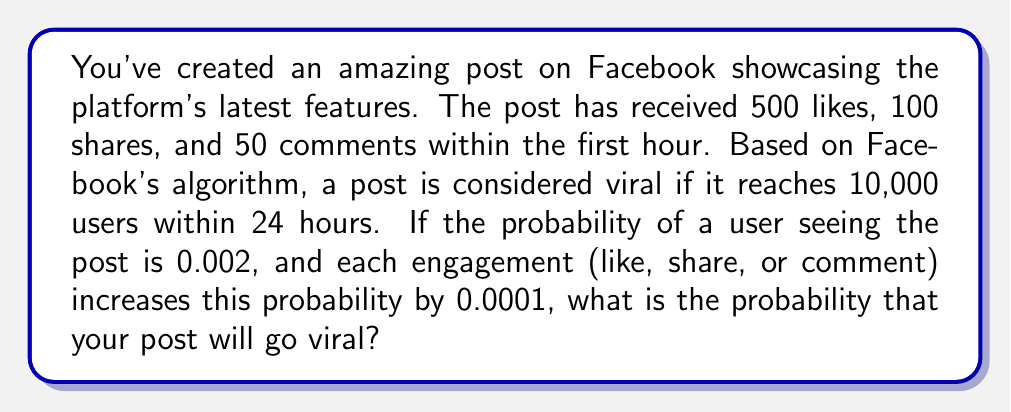Show me your answer to this math problem. Let's approach this step-by-step:

1) First, we need to calculate the adjusted probability of a user seeing the post:
   Base probability: 0.002
   Increase due to engagements: $(500 + 100 + 50) \times 0.0001 = 0.065$
   Adjusted probability: $p = 0.002 + 0.065 = 0.067$

2) The post needs to reach 10,000 users to be considered viral. We can model this as a binomial distribution, where success is defined as a user seeing the post.

3) Let $X$ be the number of users who see the post out of the total Facebook user base $n$. We want to find $P(X \geq 10000)$.

4) Given that Facebook has billions of users, we can approximate this binomial distribution with a normal distribution:
   $X \sim N(np, np(1-p))$

5) We standardize our variable:
   $$Z = \frac{X - np}{\sqrt{np(1-p)}}$$

6) Our probability becomes:
   $$P(X \geq 10000) = P\left(Z \geq \frac{10000 - np}{\sqrt{np(1-p)}}\right)$$

7) We don't know $n$, but we can estimate it conservatively at 1 billion (1,000,000,000):
   $$P\left(Z \geq \frac{10000 - 1000000000 \times 0.067}{\sqrt{1000000000 \times 0.067 \times (1-0.067)}}\right)$$

8) Simplifying:
   $$P(Z \geq -651.78)$$

9) Using a standard normal table or calculator, we find:
   $$P(Z \geq -651.78) \approx 1$$

This means the probability is extremely close to 1, or nearly certain.
Answer: $\approx 1$ (virtually certain) 